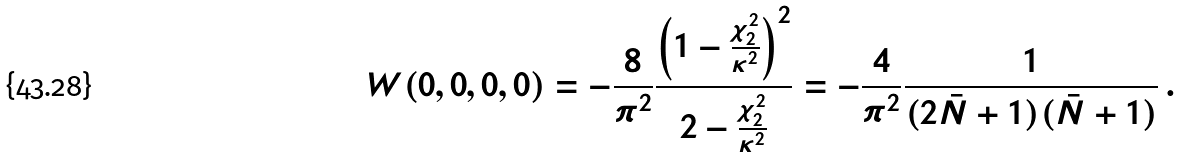Convert formula to latex. <formula><loc_0><loc_0><loc_500><loc_500>W ( 0 , 0 , 0 , 0 ) = - \frac { 8 } { \pi ^ { 2 } } \frac { \left ( 1 - \frac { \chi _ { 2 } ^ { 2 } } { \kappa ^ { 2 } } \right ) ^ { 2 } } { 2 - \frac { \chi _ { 2 } ^ { 2 } } { \kappa ^ { 2 } } } = - \frac { 4 } { \pi ^ { 2 } } \frac { 1 } { ( 2 \bar { N } + 1 ) ( \bar { N } + 1 ) } \, .</formula> 